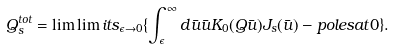Convert formula to latex. <formula><loc_0><loc_0><loc_500><loc_500>Q _ { s } ^ { t o t } = \lim \lim i t s _ { \epsilon \rightarrow 0 } \{ \int _ { \epsilon } ^ { \infty } d \bar { u } \bar { u } K _ { 0 } ( Q \bar { u } ) J _ { s } ( \bar { u } ) - p o l e s a t 0 \} .</formula> 